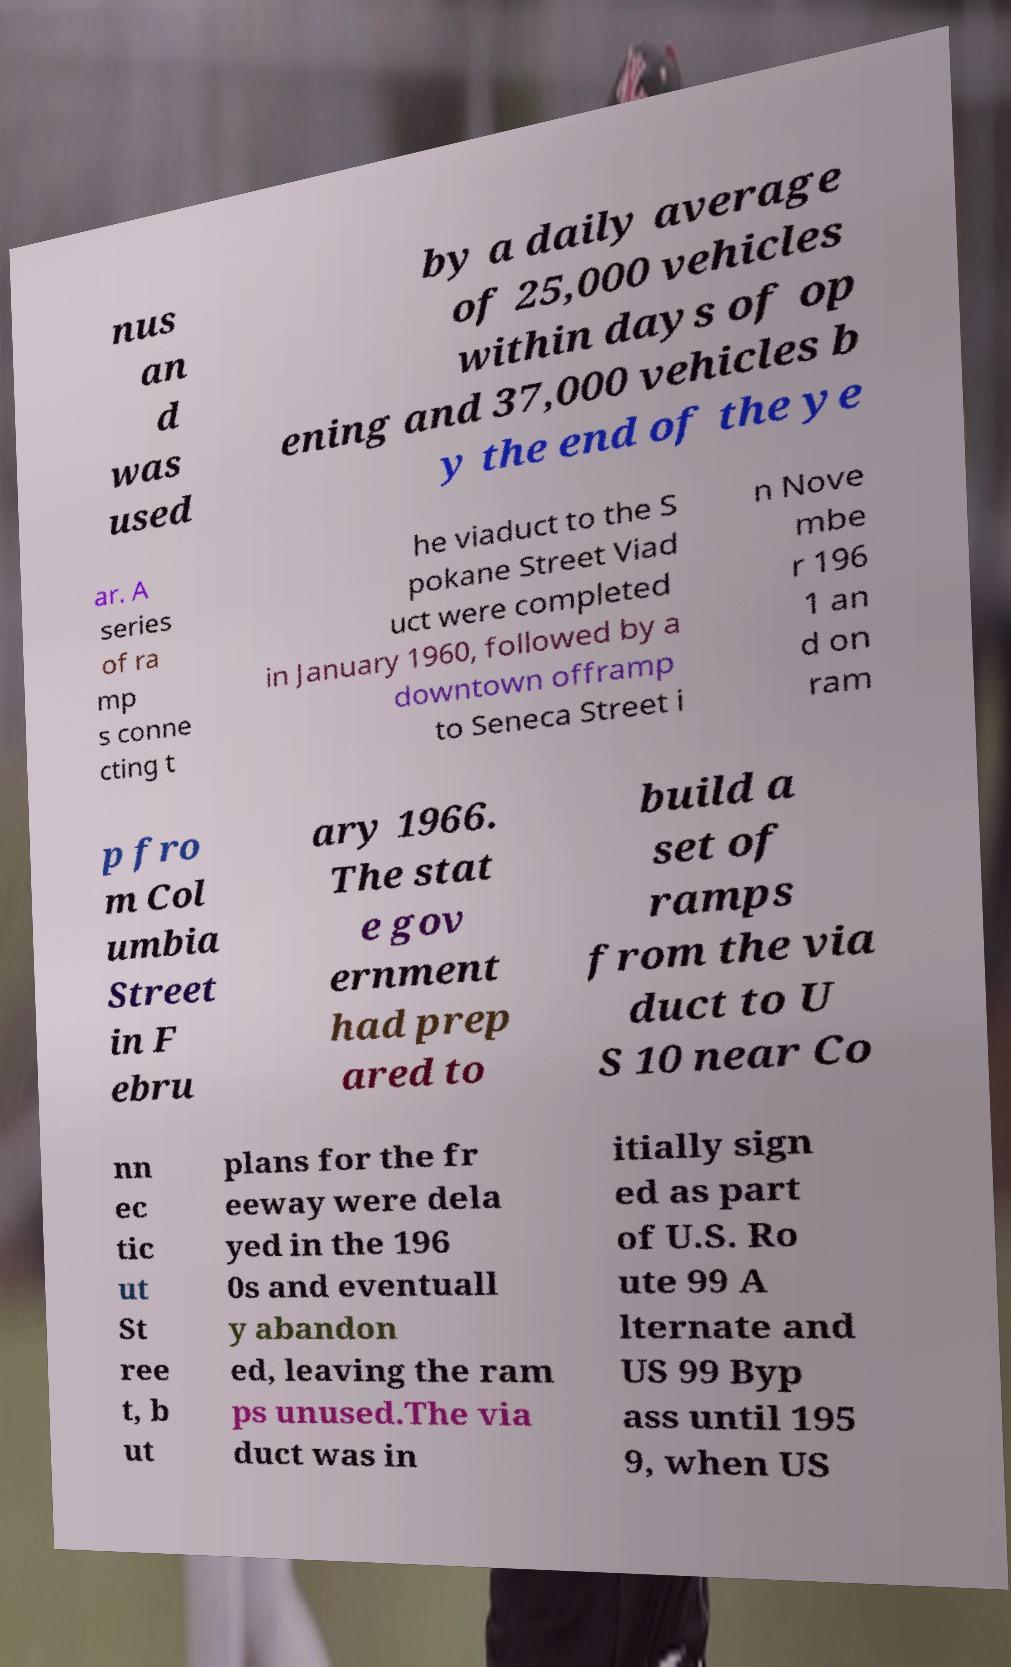Could you assist in decoding the text presented in this image and type it out clearly? nus an d was used by a daily average of 25,000 vehicles within days of op ening and 37,000 vehicles b y the end of the ye ar. A series of ra mp s conne cting t he viaduct to the S pokane Street Viad uct were completed in January 1960, followed by a downtown offramp to Seneca Street i n Nove mbe r 196 1 an d on ram p fro m Col umbia Street in F ebru ary 1966. The stat e gov ernment had prep ared to build a set of ramps from the via duct to U S 10 near Co nn ec tic ut St ree t, b ut plans for the fr eeway were dela yed in the 196 0s and eventuall y abandon ed, leaving the ram ps unused.The via duct was in itially sign ed as part of U.S. Ro ute 99 A lternate and US 99 Byp ass until 195 9, when US 